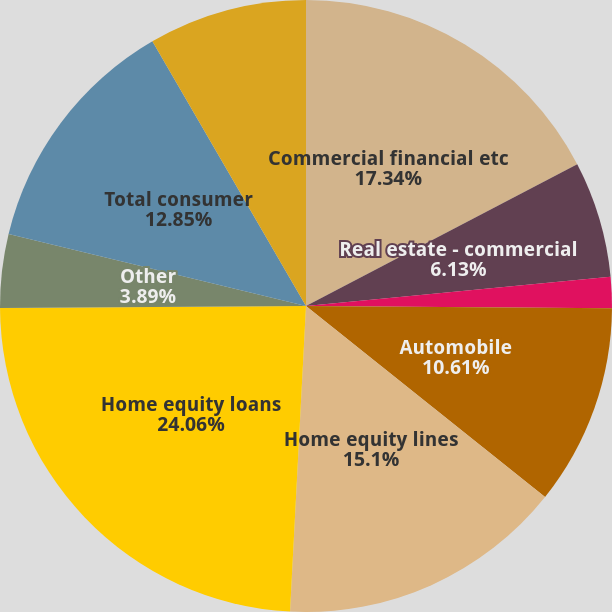<chart> <loc_0><loc_0><loc_500><loc_500><pie_chart><fcel>Commercial financial etc<fcel>Real estate - commercial<fcel>Real estate - consumer<fcel>Automobile<fcel>Home equity lines<fcel>Home equity loans<fcel>Other<fcel>Total consumer<fcel>Total<nl><fcel>17.34%<fcel>6.13%<fcel>1.65%<fcel>10.61%<fcel>15.1%<fcel>24.06%<fcel>3.89%<fcel>12.85%<fcel>8.37%<nl></chart> 